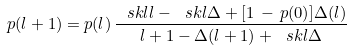<formula> <loc_0><loc_0><loc_500><loc_500>p ( l + 1 ) = p ( l ) \, \frac { \ s k l { l } - \ s k l { \Delta } + [ 1 \, - \, p ( 0 ) ] \Delta ( l ) } { l + 1 - \Delta ( l + 1 ) + \ s k l { \Delta } }</formula> 